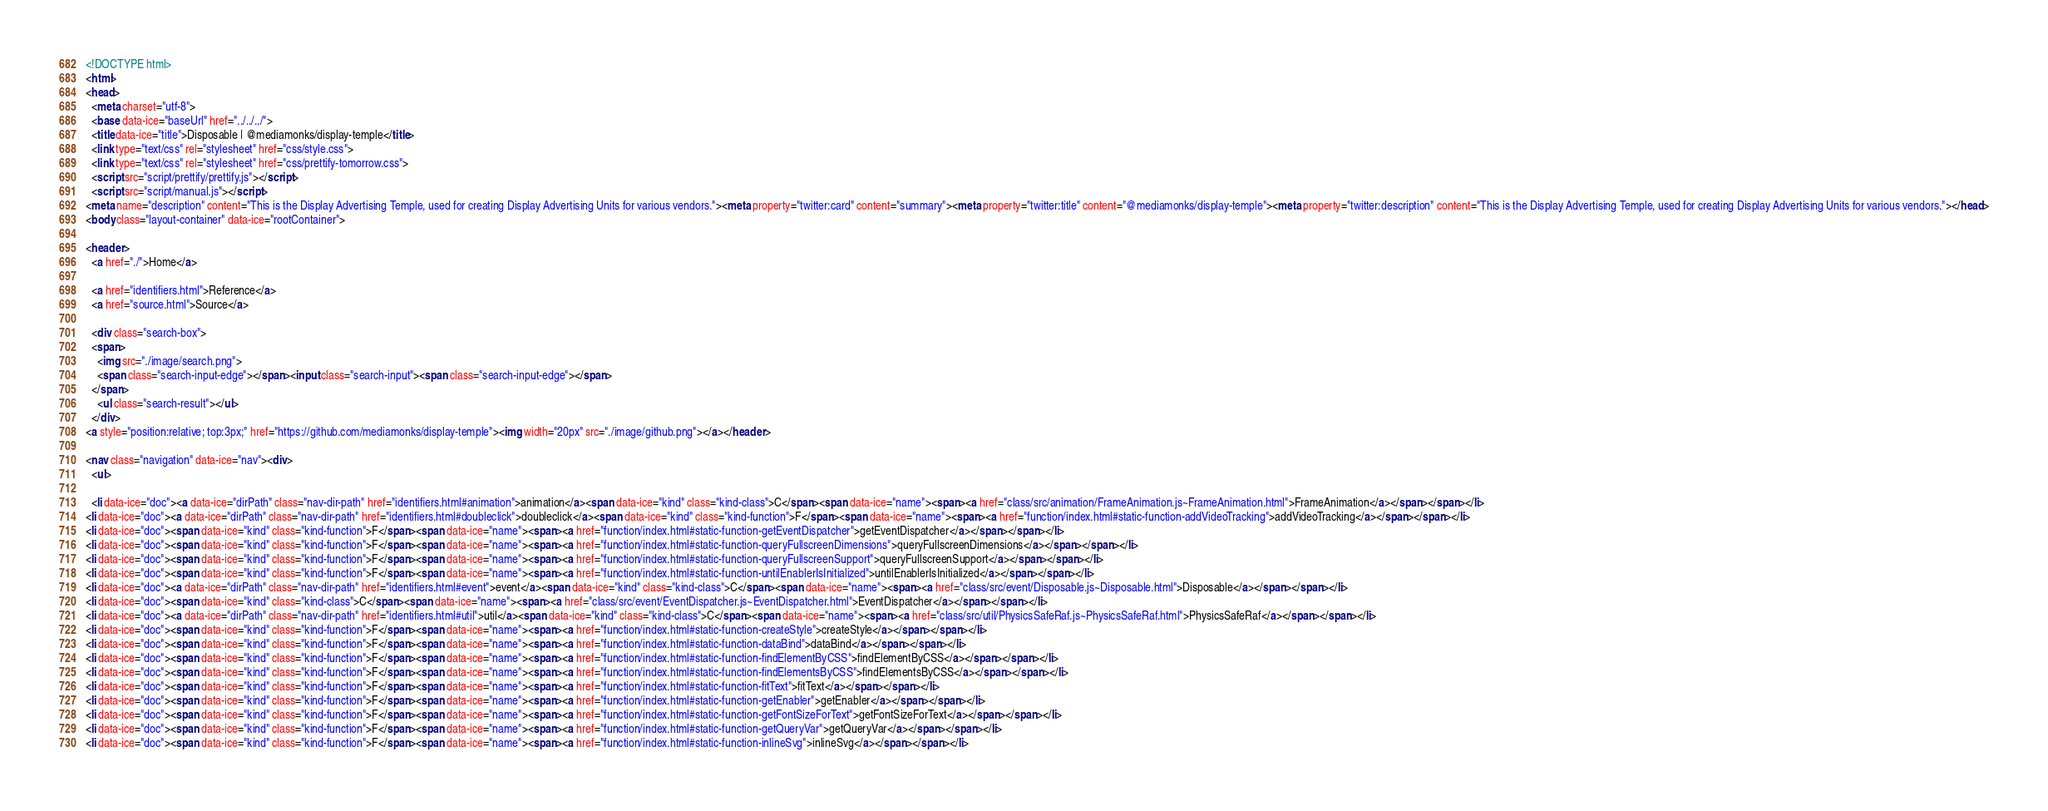<code> <loc_0><loc_0><loc_500><loc_500><_HTML_><!DOCTYPE html>
<html>
<head>
  <meta charset="utf-8">
  <base data-ice="baseUrl" href="../../../">
  <title data-ice="title">Disposable | @mediamonks/display-temple</title>
  <link type="text/css" rel="stylesheet" href="css/style.css">
  <link type="text/css" rel="stylesheet" href="css/prettify-tomorrow.css">
  <script src="script/prettify/prettify.js"></script>
  <script src="script/manual.js"></script>
<meta name="description" content="This is the Display Advertising Temple, used for creating Display Advertising Units for various vendors."><meta property="twitter:card" content="summary"><meta property="twitter:title" content="@mediamonks/display-temple"><meta property="twitter:description" content="This is the Display Advertising Temple, used for creating Display Advertising Units for various vendors."></head>
<body class="layout-container" data-ice="rootContainer">

<header>
  <a href="./">Home</a>
  
  <a href="identifiers.html">Reference</a>
  <a href="source.html">Source</a>
  
  <div class="search-box">
  <span>
    <img src="./image/search.png">
    <span class="search-input-edge"></span><input class="search-input"><span class="search-input-edge"></span>
  </span>
    <ul class="search-result"></ul>
  </div>
<a style="position:relative; top:3px;" href="https://github.com/mediamonks/display-temple"><img width="20px" src="./image/github.png"></a></header>

<nav class="navigation" data-ice="nav"><div>
  <ul>
    
  <li data-ice="doc"><a data-ice="dirPath" class="nav-dir-path" href="identifiers.html#animation">animation</a><span data-ice="kind" class="kind-class">C</span><span data-ice="name"><span><a href="class/src/animation/FrameAnimation.js~FrameAnimation.html">FrameAnimation</a></span></span></li>
<li data-ice="doc"><a data-ice="dirPath" class="nav-dir-path" href="identifiers.html#doubleclick">doubleclick</a><span data-ice="kind" class="kind-function">F</span><span data-ice="name"><span><a href="function/index.html#static-function-addVideoTracking">addVideoTracking</a></span></span></li>
<li data-ice="doc"><span data-ice="kind" class="kind-function">F</span><span data-ice="name"><span><a href="function/index.html#static-function-getEventDispatcher">getEventDispatcher</a></span></span></li>
<li data-ice="doc"><span data-ice="kind" class="kind-function">F</span><span data-ice="name"><span><a href="function/index.html#static-function-queryFullscreenDimensions">queryFullscreenDimensions</a></span></span></li>
<li data-ice="doc"><span data-ice="kind" class="kind-function">F</span><span data-ice="name"><span><a href="function/index.html#static-function-queryFullscreenSupport">queryFullscreenSupport</a></span></span></li>
<li data-ice="doc"><span data-ice="kind" class="kind-function">F</span><span data-ice="name"><span><a href="function/index.html#static-function-untilEnablerIsInitialized">untilEnablerIsInitialized</a></span></span></li>
<li data-ice="doc"><a data-ice="dirPath" class="nav-dir-path" href="identifiers.html#event">event</a><span data-ice="kind" class="kind-class">C</span><span data-ice="name"><span><a href="class/src/event/Disposable.js~Disposable.html">Disposable</a></span></span></li>
<li data-ice="doc"><span data-ice="kind" class="kind-class">C</span><span data-ice="name"><span><a href="class/src/event/EventDispatcher.js~EventDispatcher.html">EventDispatcher</a></span></span></li>
<li data-ice="doc"><a data-ice="dirPath" class="nav-dir-path" href="identifiers.html#util">util</a><span data-ice="kind" class="kind-class">C</span><span data-ice="name"><span><a href="class/src/util/PhysicsSafeRaf.js~PhysicsSafeRaf.html">PhysicsSafeRaf</a></span></span></li>
<li data-ice="doc"><span data-ice="kind" class="kind-function">F</span><span data-ice="name"><span><a href="function/index.html#static-function-createStyle">createStyle</a></span></span></li>
<li data-ice="doc"><span data-ice="kind" class="kind-function">F</span><span data-ice="name"><span><a href="function/index.html#static-function-dataBind">dataBind</a></span></span></li>
<li data-ice="doc"><span data-ice="kind" class="kind-function">F</span><span data-ice="name"><span><a href="function/index.html#static-function-findElementByCSS">findElementByCSS</a></span></span></li>
<li data-ice="doc"><span data-ice="kind" class="kind-function">F</span><span data-ice="name"><span><a href="function/index.html#static-function-findElementsByCSS">findElementsByCSS</a></span></span></li>
<li data-ice="doc"><span data-ice="kind" class="kind-function">F</span><span data-ice="name"><span><a href="function/index.html#static-function-fitText">fitText</a></span></span></li>
<li data-ice="doc"><span data-ice="kind" class="kind-function">F</span><span data-ice="name"><span><a href="function/index.html#static-function-getEnabler">getEnabler</a></span></span></li>
<li data-ice="doc"><span data-ice="kind" class="kind-function">F</span><span data-ice="name"><span><a href="function/index.html#static-function-getFontSizeForText">getFontSizeForText</a></span></span></li>
<li data-ice="doc"><span data-ice="kind" class="kind-function">F</span><span data-ice="name"><span><a href="function/index.html#static-function-getQueryVar">getQueryVar</a></span></span></li>
<li data-ice="doc"><span data-ice="kind" class="kind-function">F</span><span data-ice="name"><span><a href="function/index.html#static-function-inlineSvg">inlineSvg</a></span></span></li></code> 